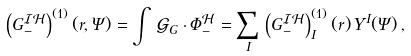Convert formula to latex. <formula><loc_0><loc_0><loc_500><loc_500>\left ( G _ { - } ^ { \mathcal { I H } } \right ) ^ { ( 1 ) } ( r , \Psi ) = \int \, \mathcal { G } _ { G } \cdot \Phi _ { - } ^ { \mathcal { H } } = \sum _ { I } \, \left ( G _ { - } ^ { \mathcal { I H } } \right ) _ { I } ^ { ( 1 ) } ( r ) \, Y ^ { I } ( \Psi ) \, ,</formula> 